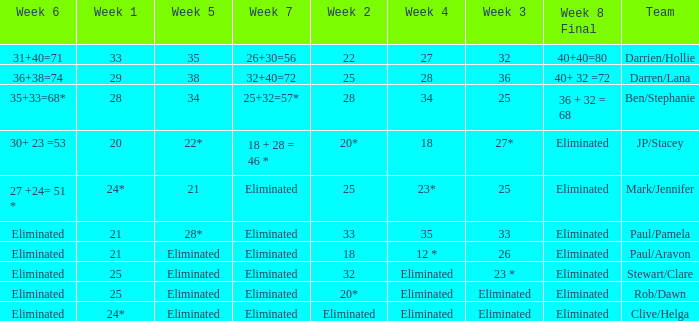Name the week 3 with week 6 of 31+40=71 32.0. 